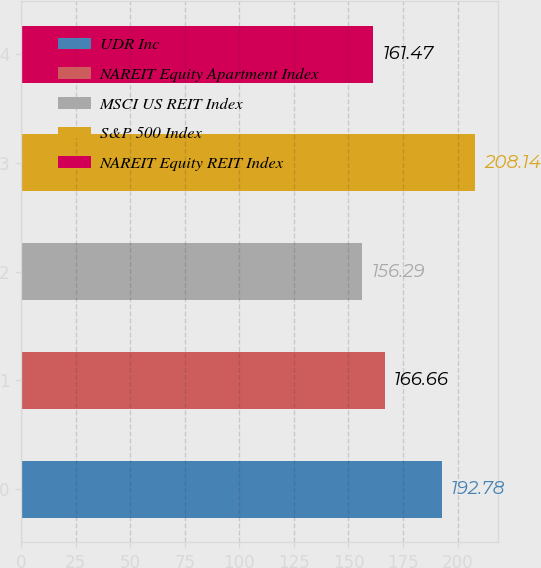<chart> <loc_0><loc_0><loc_500><loc_500><bar_chart><fcel>UDR Inc<fcel>NAREIT Equity Apartment Index<fcel>MSCI US REIT Index<fcel>S&P 500 Index<fcel>NAREIT Equity REIT Index<nl><fcel>192.78<fcel>166.66<fcel>156.29<fcel>208.14<fcel>161.47<nl></chart> 